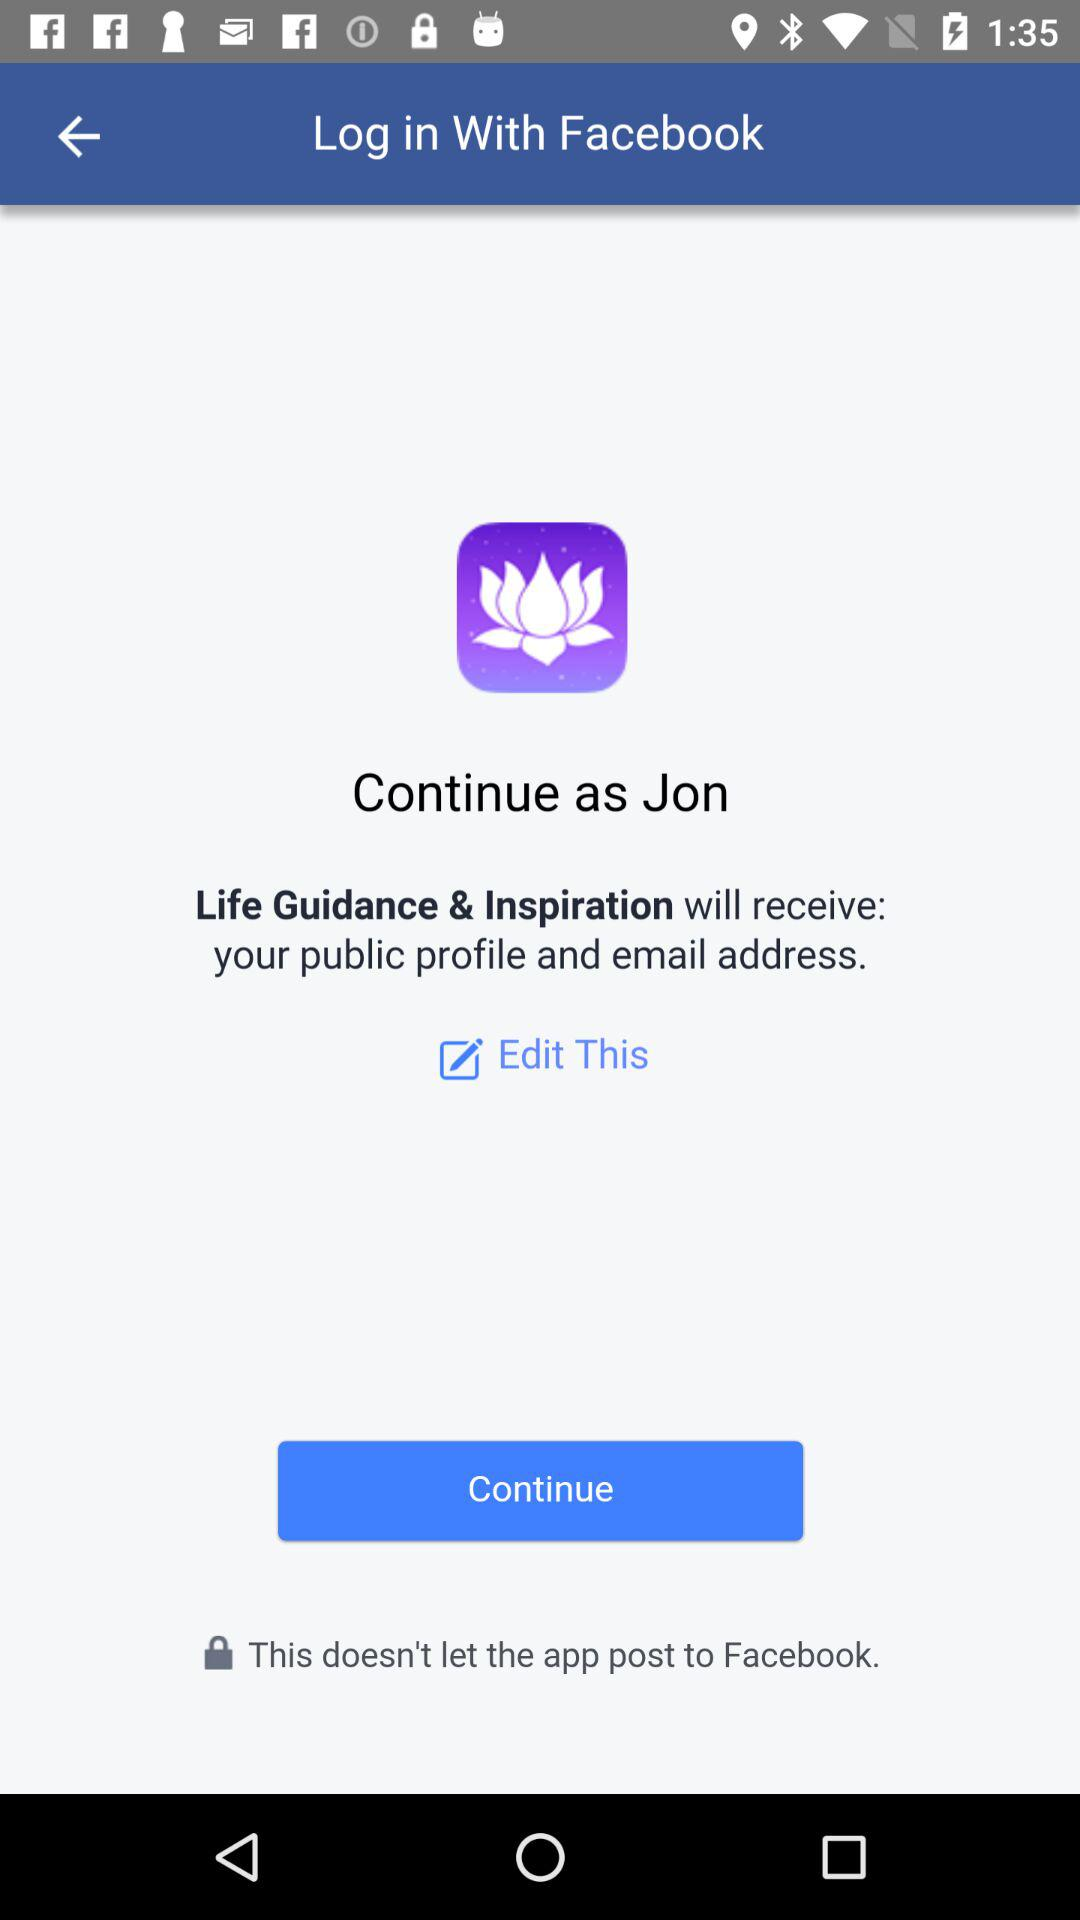What is the application to access? The application is "Facebook". 